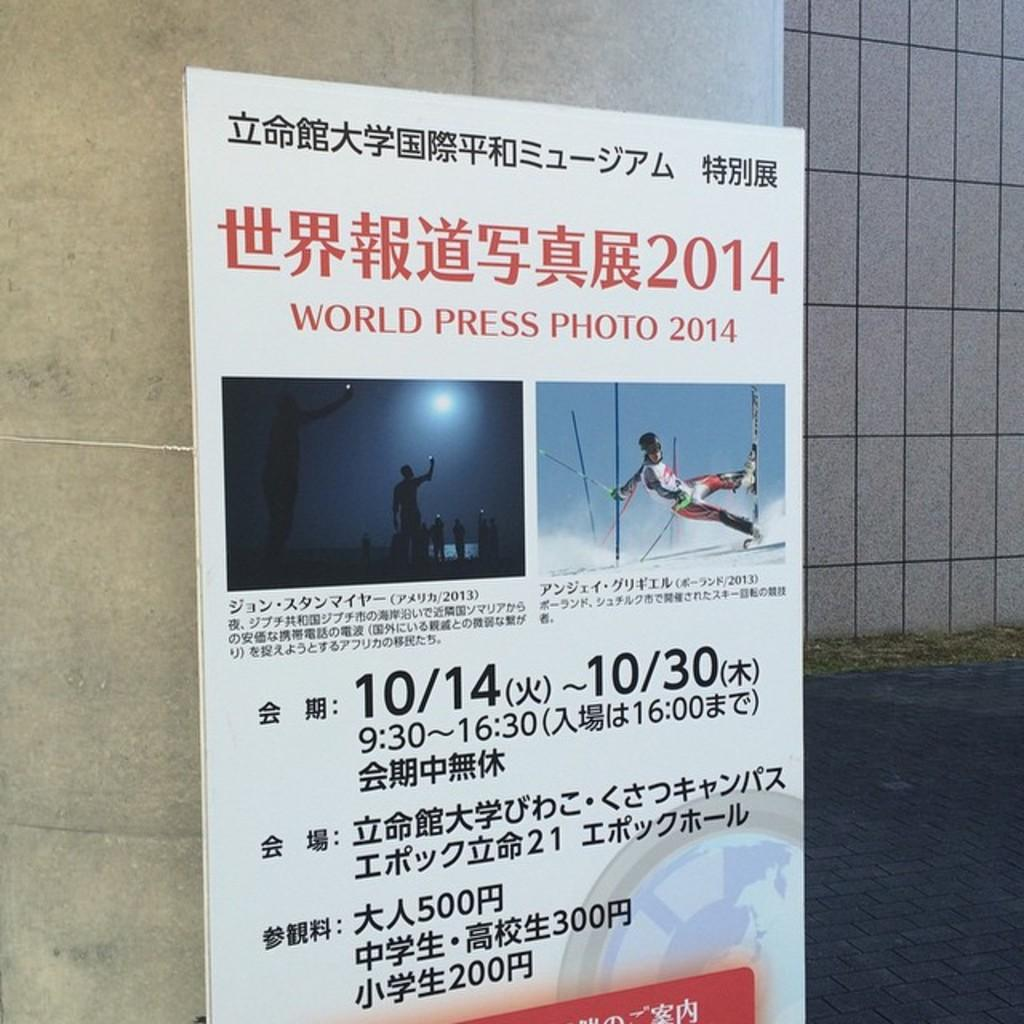<image>
Share a concise interpretation of the image provided. The World Press Photo 2014 show runs from 10/14-10/30. 